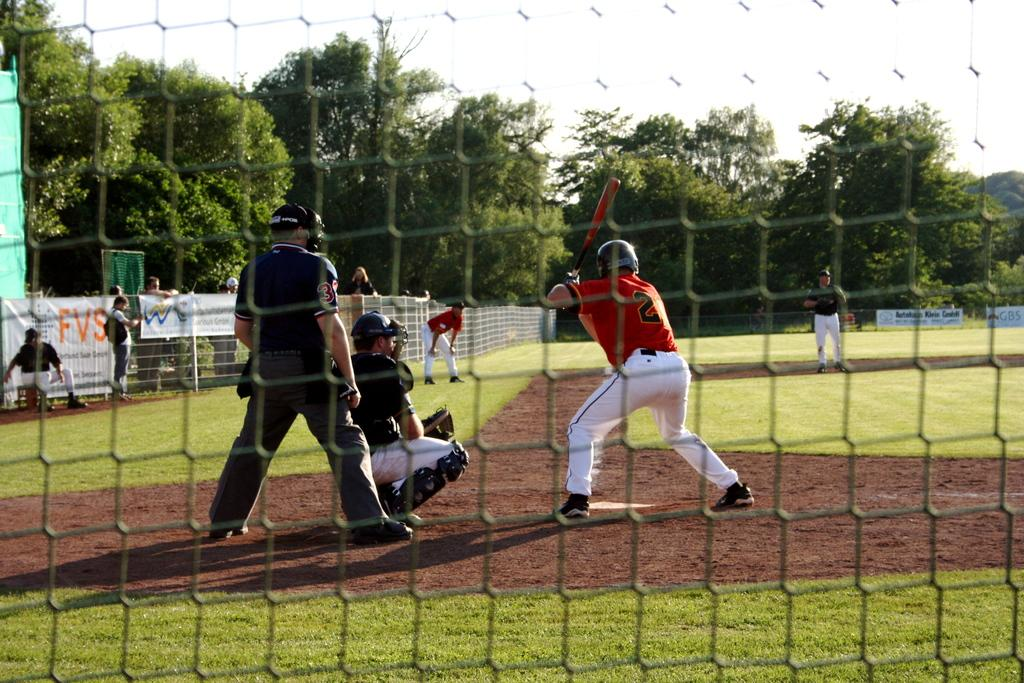<image>
Provide a brief description of the given image. a player in orange with the number 2 on his back 